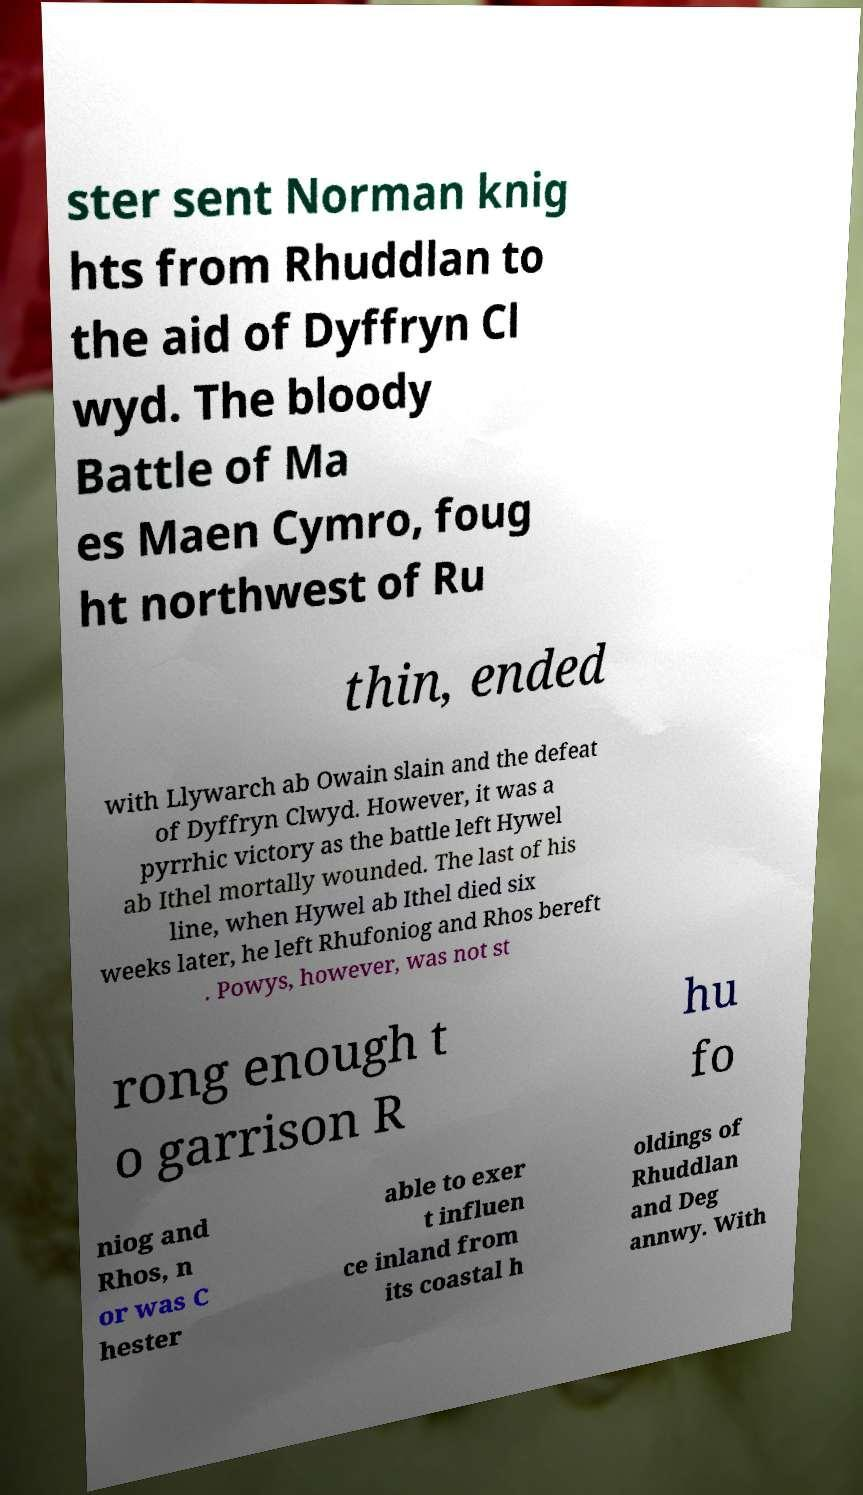Could you assist in decoding the text presented in this image and type it out clearly? ster sent Norman knig hts from Rhuddlan to the aid of Dyffryn Cl wyd. The bloody Battle of Ma es Maen Cymro, foug ht northwest of Ru thin, ended with Llywarch ab Owain slain and the defeat of Dyffryn Clwyd. However, it was a pyrrhic victory as the battle left Hywel ab Ithel mortally wounded. The last of his line, when Hywel ab Ithel died six weeks later, he left Rhufoniog and Rhos bereft . Powys, however, was not st rong enough t o garrison R hu fo niog and Rhos, n or was C hester able to exer t influen ce inland from its coastal h oldings of Rhuddlan and Deg annwy. With 